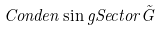<formula> <loc_0><loc_0><loc_500><loc_500>C o n d e n \sin g S e c t o r \tilde { G }</formula> 